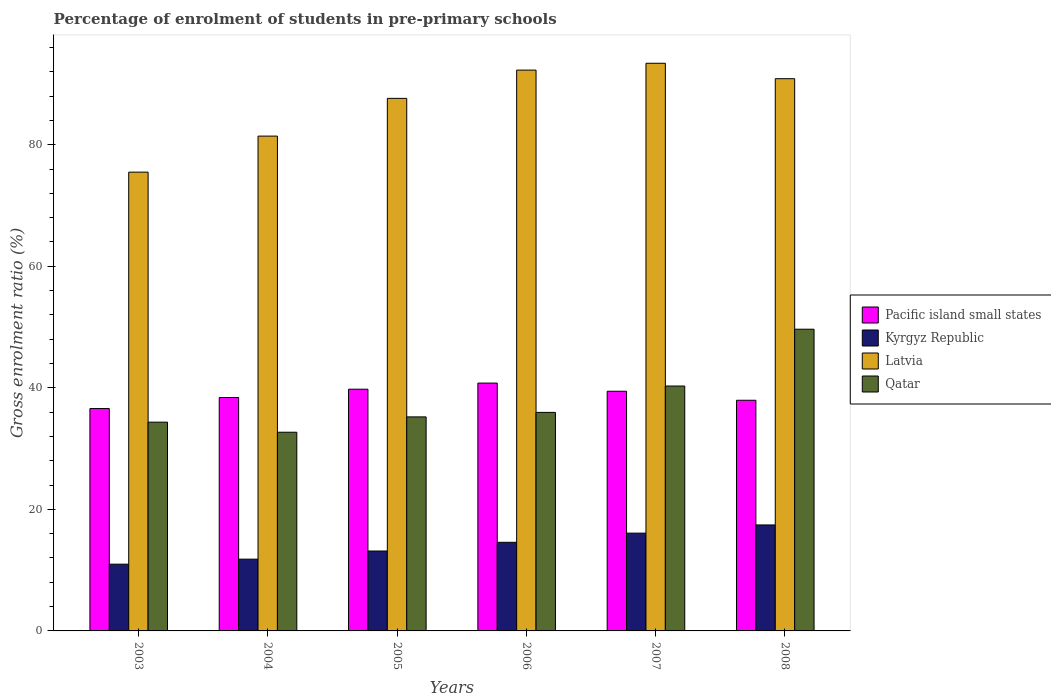How many bars are there on the 5th tick from the left?
Your answer should be compact. 4. What is the label of the 3rd group of bars from the left?
Offer a very short reply. 2005. What is the percentage of students enrolled in pre-primary schools in Pacific island small states in 2006?
Ensure brevity in your answer.  40.78. Across all years, what is the maximum percentage of students enrolled in pre-primary schools in Kyrgyz Republic?
Provide a succinct answer. 17.44. Across all years, what is the minimum percentage of students enrolled in pre-primary schools in Pacific island small states?
Your response must be concise. 36.59. In which year was the percentage of students enrolled in pre-primary schools in Kyrgyz Republic maximum?
Keep it short and to the point. 2008. In which year was the percentage of students enrolled in pre-primary schools in Latvia minimum?
Give a very brief answer. 2003. What is the total percentage of students enrolled in pre-primary schools in Pacific island small states in the graph?
Offer a terse response. 232.95. What is the difference between the percentage of students enrolled in pre-primary schools in Pacific island small states in 2006 and that in 2007?
Keep it short and to the point. 1.34. What is the difference between the percentage of students enrolled in pre-primary schools in Qatar in 2008 and the percentage of students enrolled in pre-primary schools in Latvia in 2004?
Keep it short and to the point. -31.78. What is the average percentage of students enrolled in pre-primary schools in Pacific island small states per year?
Give a very brief answer. 38.83. In the year 2007, what is the difference between the percentage of students enrolled in pre-primary schools in Latvia and percentage of students enrolled in pre-primary schools in Pacific island small states?
Provide a short and direct response. 53.97. What is the ratio of the percentage of students enrolled in pre-primary schools in Latvia in 2004 to that in 2008?
Keep it short and to the point. 0.9. Is the percentage of students enrolled in pre-primary schools in Kyrgyz Republic in 2003 less than that in 2004?
Provide a short and direct response. Yes. Is the difference between the percentage of students enrolled in pre-primary schools in Latvia in 2004 and 2008 greater than the difference between the percentage of students enrolled in pre-primary schools in Pacific island small states in 2004 and 2008?
Keep it short and to the point. No. What is the difference between the highest and the second highest percentage of students enrolled in pre-primary schools in Kyrgyz Republic?
Ensure brevity in your answer.  1.35. What is the difference between the highest and the lowest percentage of students enrolled in pre-primary schools in Kyrgyz Republic?
Offer a terse response. 6.45. In how many years, is the percentage of students enrolled in pre-primary schools in Latvia greater than the average percentage of students enrolled in pre-primary schools in Latvia taken over all years?
Provide a succinct answer. 4. Is the sum of the percentage of students enrolled in pre-primary schools in Kyrgyz Republic in 2005 and 2006 greater than the maximum percentage of students enrolled in pre-primary schools in Latvia across all years?
Offer a very short reply. No. Is it the case that in every year, the sum of the percentage of students enrolled in pre-primary schools in Kyrgyz Republic and percentage of students enrolled in pre-primary schools in Pacific island small states is greater than the sum of percentage of students enrolled in pre-primary schools in Qatar and percentage of students enrolled in pre-primary schools in Latvia?
Provide a succinct answer. No. What does the 3rd bar from the left in 2007 represents?
Provide a short and direct response. Latvia. What does the 3rd bar from the right in 2005 represents?
Make the answer very short. Kyrgyz Republic. What is the difference between two consecutive major ticks on the Y-axis?
Your answer should be very brief. 20. Does the graph contain grids?
Provide a short and direct response. No. How many legend labels are there?
Keep it short and to the point. 4. What is the title of the graph?
Give a very brief answer. Percentage of enrolment of students in pre-primary schools. What is the label or title of the Y-axis?
Give a very brief answer. Gross enrolment ratio (%). What is the Gross enrolment ratio (%) in Pacific island small states in 2003?
Provide a short and direct response. 36.59. What is the Gross enrolment ratio (%) of Kyrgyz Republic in 2003?
Your answer should be very brief. 10.99. What is the Gross enrolment ratio (%) of Latvia in 2003?
Your response must be concise. 75.5. What is the Gross enrolment ratio (%) of Qatar in 2003?
Ensure brevity in your answer.  34.35. What is the Gross enrolment ratio (%) of Pacific island small states in 2004?
Ensure brevity in your answer.  38.41. What is the Gross enrolment ratio (%) in Kyrgyz Republic in 2004?
Your answer should be compact. 11.81. What is the Gross enrolment ratio (%) of Latvia in 2004?
Ensure brevity in your answer.  81.43. What is the Gross enrolment ratio (%) of Qatar in 2004?
Your answer should be very brief. 32.7. What is the Gross enrolment ratio (%) of Pacific island small states in 2005?
Give a very brief answer. 39.78. What is the Gross enrolment ratio (%) of Kyrgyz Republic in 2005?
Provide a succinct answer. 13.15. What is the Gross enrolment ratio (%) in Latvia in 2005?
Your answer should be compact. 87.63. What is the Gross enrolment ratio (%) of Qatar in 2005?
Your response must be concise. 35.22. What is the Gross enrolment ratio (%) of Pacific island small states in 2006?
Offer a terse response. 40.78. What is the Gross enrolment ratio (%) of Kyrgyz Republic in 2006?
Provide a succinct answer. 14.58. What is the Gross enrolment ratio (%) of Latvia in 2006?
Provide a short and direct response. 92.29. What is the Gross enrolment ratio (%) of Qatar in 2006?
Make the answer very short. 35.96. What is the Gross enrolment ratio (%) of Pacific island small states in 2007?
Keep it short and to the point. 39.44. What is the Gross enrolment ratio (%) of Kyrgyz Republic in 2007?
Your answer should be very brief. 16.09. What is the Gross enrolment ratio (%) of Latvia in 2007?
Provide a short and direct response. 93.41. What is the Gross enrolment ratio (%) of Qatar in 2007?
Ensure brevity in your answer.  40.3. What is the Gross enrolment ratio (%) in Pacific island small states in 2008?
Ensure brevity in your answer.  37.96. What is the Gross enrolment ratio (%) in Kyrgyz Republic in 2008?
Provide a short and direct response. 17.44. What is the Gross enrolment ratio (%) in Latvia in 2008?
Your answer should be compact. 90.87. What is the Gross enrolment ratio (%) of Qatar in 2008?
Ensure brevity in your answer.  49.65. Across all years, what is the maximum Gross enrolment ratio (%) in Pacific island small states?
Your response must be concise. 40.78. Across all years, what is the maximum Gross enrolment ratio (%) in Kyrgyz Republic?
Ensure brevity in your answer.  17.44. Across all years, what is the maximum Gross enrolment ratio (%) in Latvia?
Offer a very short reply. 93.41. Across all years, what is the maximum Gross enrolment ratio (%) of Qatar?
Your answer should be very brief. 49.65. Across all years, what is the minimum Gross enrolment ratio (%) of Pacific island small states?
Ensure brevity in your answer.  36.59. Across all years, what is the minimum Gross enrolment ratio (%) of Kyrgyz Republic?
Provide a short and direct response. 10.99. Across all years, what is the minimum Gross enrolment ratio (%) of Latvia?
Provide a short and direct response. 75.5. Across all years, what is the minimum Gross enrolment ratio (%) of Qatar?
Your response must be concise. 32.7. What is the total Gross enrolment ratio (%) of Pacific island small states in the graph?
Make the answer very short. 232.95. What is the total Gross enrolment ratio (%) in Kyrgyz Republic in the graph?
Your answer should be very brief. 84.06. What is the total Gross enrolment ratio (%) of Latvia in the graph?
Your response must be concise. 521.13. What is the total Gross enrolment ratio (%) of Qatar in the graph?
Ensure brevity in your answer.  228.18. What is the difference between the Gross enrolment ratio (%) in Pacific island small states in 2003 and that in 2004?
Give a very brief answer. -1.81. What is the difference between the Gross enrolment ratio (%) in Kyrgyz Republic in 2003 and that in 2004?
Your answer should be compact. -0.83. What is the difference between the Gross enrolment ratio (%) in Latvia in 2003 and that in 2004?
Ensure brevity in your answer.  -5.93. What is the difference between the Gross enrolment ratio (%) of Qatar in 2003 and that in 2004?
Make the answer very short. 1.66. What is the difference between the Gross enrolment ratio (%) of Pacific island small states in 2003 and that in 2005?
Offer a terse response. -3.18. What is the difference between the Gross enrolment ratio (%) of Kyrgyz Republic in 2003 and that in 2005?
Provide a short and direct response. -2.17. What is the difference between the Gross enrolment ratio (%) of Latvia in 2003 and that in 2005?
Give a very brief answer. -12.14. What is the difference between the Gross enrolment ratio (%) of Qatar in 2003 and that in 2005?
Provide a short and direct response. -0.86. What is the difference between the Gross enrolment ratio (%) in Pacific island small states in 2003 and that in 2006?
Offer a very short reply. -4.19. What is the difference between the Gross enrolment ratio (%) of Kyrgyz Republic in 2003 and that in 2006?
Offer a terse response. -3.6. What is the difference between the Gross enrolment ratio (%) of Latvia in 2003 and that in 2006?
Give a very brief answer. -16.79. What is the difference between the Gross enrolment ratio (%) in Qatar in 2003 and that in 2006?
Provide a succinct answer. -1.6. What is the difference between the Gross enrolment ratio (%) in Pacific island small states in 2003 and that in 2007?
Provide a short and direct response. -2.85. What is the difference between the Gross enrolment ratio (%) of Kyrgyz Republic in 2003 and that in 2007?
Provide a succinct answer. -5.11. What is the difference between the Gross enrolment ratio (%) in Latvia in 2003 and that in 2007?
Make the answer very short. -17.91. What is the difference between the Gross enrolment ratio (%) of Qatar in 2003 and that in 2007?
Ensure brevity in your answer.  -5.95. What is the difference between the Gross enrolment ratio (%) of Pacific island small states in 2003 and that in 2008?
Your response must be concise. -1.37. What is the difference between the Gross enrolment ratio (%) of Kyrgyz Republic in 2003 and that in 2008?
Keep it short and to the point. -6.45. What is the difference between the Gross enrolment ratio (%) of Latvia in 2003 and that in 2008?
Offer a very short reply. -15.37. What is the difference between the Gross enrolment ratio (%) in Qatar in 2003 and that in 2008?
Your answer should be very brief. -15.29. What is the difference between the Gross enrolment ratio (%) of Pacific island small states in 2004 and that in 2005?
Offer a terse response. -1.37. What is the difference between the Gross enrolment ratio (%) in Kyrgyz Republic in 2004 and that in 2005?
Offer a terse response. -1.34. What is the difference between the Gross enrolment ratio (%) in Latvia in 2004 and that in 2005?
Offer a very short reply. -6.21. What is the difference between the Gross enrolment ratio (%) in Qatar in 2004 and that in 2005?
Ensure brevity in your answer.  -2.52. What is the difference between the Gross enrolment ratio (%) in Pacific island small states in 2004 and that in 2006?
Provide a succinct answer. -2.38. What is the difference between the Gross enrolment ratio (%) of Kyrgyz Republic in 2004 and that in 2006?
Provide a succinct answer. -2.77. What is the difference between the Gross enrolment ratio (%) in Latvia in 2004 and that in 2006?
Keep it short and to the point. -10.86. What is the difference between the Gross enrolment ratio (%) in Qatar in 2004 and that in 2006?
Your answer should be very brief. -3.26. What is the difference between the Gross enrolment ratio (%) of Pacific island small states in 2004 and that in 2007?
Offer a terse response. -1.04. What is the difference between the Gross enrolment ratio (%) of Kyrgyz Republic in 2004 and that in 2007?
Keep it short and to the point. -4.28. What is the difference between the Gross enrolment ratio (%) in Latvia in 2004 and that in 2007?
Your answer should be very brief. -11.99. What is the difference between the Gross enrolment ratio (%) of Qatar in 2004 and that in 2007?
Provide a succinct answer. -7.6. What is the difference between the Gross enrolment ratio (%) of Pacific island small states in 2004 and that in 2008?
Ensure brevity in your answer.  0.45. What is the difference between the Gross enrolment ratio (%) of Kyrgyz Republic in 2004 and that in 2008?
Give a very brief answer. -5.63. What is the difference between the Gross enrolment ratio (%) in Latvia in 2004 and that in 2008?
Provide a short and direct response. -9.45. What is the difference between the Gross enrolment ratio (%) in Qatar in 2004 and that in 2008?
Your answer should be very brief. -16.95. What is the difference between the Gross enrolment ratio (%) of Pacific island small states in 2005 and that in 2006?
Provide a succinct answer. -1.01. What is the difference between the Gross enrolment ratio (%) of Kyrgyz Republic in 2005 and that in 2006?
Provide a succinct answer. -1.43. What is the difference between the Gross enrolment ratio (%) of Latvia in 2005 and that in 2006?
Your answer should be compact. -4.65. What is the difference between the Gross enrolment ratio (%) of Qatar in 2005 and that in 2006?
Give a very brief answer. -0.74. What is the difference between the Gross enrolment ratio (%) in Pacific island small states in 2005 and that in 2007?
Offer a very short reply. 0.33. What is the difference between the Gross enrolment ratio (%) of Kyrgyz Republic in 2005 and that in 2007?
Your answer should be very brief. -2.94. What is the difference between the Gross enrolment ratio (%) in Latvia in 2005 and that in 2007?
Offer a very short reply. -5.78. What is the difference between the Gross enrolment ratio (%) in Qatar in 2005 and that in 2007?
Offer a very short reply. -5.08. What is the difference between the Gross enrolment ratio (%) in Pacific island small states in 2005 and that in 2008?
Provide a succinct answer. 1.82. What is the difference between the Gross enrolment ratio (%) in Kyrgyz Republic in 2005 and that in 2008?
Offer a very short reply. -4.29. What is the difference between the Gross enrolment ratio (%) of Latvia in 2005 and that in 2008?
Offer a very short reply. -3.24. What is the difference between the Gross enrolment ratio (%) in Qatar in 2005 and that in 2008?
Your answer should be compact. -14.43. What is the difference between the Gross enrolment ratio (%) of Pacific island small states in 2006 and that in 2007?
Offer a terse response. 1.34. What is the difference between the Gross enrolment ratio (%) in Kyrgyz Republic in 2006 and that in 2007?
Offer a very short reply. -1.51. What is the difference between the Gross enrolment ratio (%) in Latvia in 2006 and that in 2007?
Make the answer very short. -1.13. What is the difference between the Gross enrolment ratio (%) of Qatar in 2006 and that in 2007?
Your response must be concise. -4.34. What is the difference between the Gross enrolment ratio (%) of Pacific island small states in 2006 and that in 2008?
Offer a terse response. 2.83. What is the difference between the Gross enrolment ratio (%) in Kyrgyz Republic in 2006 and that in 2008?
Ensure brevity in your answer.  -2.85. What is the difference between the Gross enrolment ratio (%) in Latvia in 2006 and that in 2008?
Provide a succinct answer. 1.41. What is the difference between the Gross enrolment ratio (%) of Qatar in 2006 and that in 2008?
Offer a very short reply. -13.69. What is the difference between the Gross enrolment ratio (%) in Pacific island small states in 2007 and that in 2008?
Keep it short and to the point. 1.48. What is the difference between the Gross enrolment ratio (%) in Kyrgyz Republic in 2007 and that in 2008?
Your response must be concise. -1.35. What is the difference between the Gross enrolment ratio (%) of Latvia in 2007 and that in 2008?
Give a very brief answer. 2.54. What is the difference between the Gross enrolment ratio (%) of Qatar in 2007 and that in 2008?
Your answer should be compact. -9.35. What is the difference between the Gross enrolment ratio (%) of Pacific island small states in 2003 and the Gross enrolment ratio (%) of Kyrgyz Republic in 2004?
Give a very brief answer. 24.78. What is the difference between the Gross enrolment ratio (%) of Pacific island small states in 2003 and the Gross enrolment ratio (%) of Latvia in 2004?
Your response must be concise. -44.83. What is the difference between the Gross enrolment ratio (%) in Pacific island small states in 2003 and the Gross enrolment ratio (%) in Qatar in 2004?
Keep it short and to the point. 3.89. What is the difference between the Gross enrolment ratio (%) in Kyrgyz Republic in 2003 and the Gross enrolment ratio (%) in Latvia in 2004?
Make the answer very short. -70.44. What is the difference between the Gross enrolment ratio (%) of Kyrgyz Republic in 2003 and the Gross enrolment ratio (%) of Qatar in 2004?
Ensure brevity in your answer.  -21.71. What is the difference between the Gross enrolment ratio (%) of Latvia in 2003 and the Gross enrolment ratio (%) of Qatar in 2004?
Offer a very short reply. 42.8. What is the difference between the Gross enrolment ratio (%) in Pacific island small states in 2003 and the Gross enrolment ratio (%) in Kyrgyz Republic in 2005?
Keep it short and to the point. 23.44. What is the difference between the Gross enrolment ratio (%) of Pacific island small states in 2003 and the Gross enrolment ratio (%) of Latvia in 2005?
Keep it short and to the point. -51.04. What is the difference between the Gross enrolment ratio (%) in Pacific island small states in 2003 and the Gross enrolment ratio (%) in Qatar in 2005?
Your answer should be compact. 1.37. What is the difference between the Gross enrolment ratio (%) in Kyrgyz Republic in 2003 and the Gross enrolment ratio (%) in Latvia in 2005?
Make the answer very short. -76.65. What is the difference between the Gross enrolment ratio (%) of Kyrgyz Republic in 2003 and the Gross enrolment ratio (%) of Qatar in 2005?
Offer a terse response. -24.23. What is the difference between the Gross enrolment ratio (%) of Latvia in 2003 and the Gross enrolment ratio (%) of Qatar in 2005?
Offer a terse response. 40.28. What is the difference between the Gross enrolment ratio (%) in Pacific island small states in 2003 and the Gross enrolment ratio (%) in Kyrgyz Republic in 2006?
Your answer should be compact. 22.01. What is the difference between the Gross enrolment ratio (%) of Pacific island small states in 2003 and the Gross enrolment ratio (%) of Latvia in 2006?
Give a very brief answer. -55.69. What is the difference between the Gross enrolment ratio (%) in Pacific island small states in 2003 and the Gross enrolment ratio (%) in Qatar in 2006?
Your response must be concise. 0.63. What is the difference between the Gross enrolment ratio (%) of Kyrgyz Republic in 2003 and the Gross enrolment ratio (%) of Latvia in 2006?
Provide a short and direct response. -81.3. What is the difference between the Gross enrolment ratio (%) in Kyrgyz Republic in 2003 and the Gross enrolment ratio (%) in Qatar in 2006?
Provide a succinct answer. -24.97. What is the difference between the Gross enrolment ratio (%) in Latvia in 2003 and the Gross enrolment ratio (%) in Qatar in 2006?
Make the answer very short. 39.54. What is the difference between the Gross enrolment ratio (%) in Pacific island small states in 2003 and the Gross enrolment ratio (%) in Kyrgyz Republic in 2007?
Your response must be concise. 20.5. What is the difference between the Gross enrolment ratio (%) in Pacific island small states in 2003 and the Gross enrolment ratio (%) in Latvia in 2007?
Your answer should be compact. -56.82. What is the difference between the Gross enrolment ratio (%) in Pacific island small states in 2003 and the Gross enrolment ratio (%) in Qatar in 2007?
Make the answer very short. -3.71. What is the difference between the Gross enrolment ratio (%) of Kyrgyz Republic in 2003 and the Gross enrolment ratio (%) of Latvia in 2007?
Offer a terse response. -82.43. What is the difference between the Gross enrolment ratio (%) of Kyrgyz Republic in 2003 and the Gross enrolment ratio (%) of Qatar in 2007?
Your answer should be very brief. -29.32. What is the difference between the Gross enrolment ratio (%) of Latvia in 2003 and the Gross enrolment ratio (%) of Qatar in 2007?
Offer a terse response. 35.2. What is the difference between the Gross enrolment ratio (%) of Pacific island small states in 2003 and the Gross enrolment ratio (%) of Kyrgyz Republic in 2008?
Your answer should be very brief. 19.15. What is the difference between the Gross enrolment ratio (%) in Pacific island small states in 2003 and the Gross enrolment ratio (%) in Latvia in 2008?
Make the answer very short. -54.28. What is the difference between the Gross enrolment ratio (%) in Pacific island small states in 2003 and the Gross enrolment ratio (%) in Qatar in 2008?
Your answer should be very brief. -13.06. What is the difference between the Gross enrolment ratio (%) in Kyrgyz Republic in 2003 and the Gross enrolment ratio (%) in Latvia in 2008?
Give a very brief answer. -79.89. What is the difference between the Gross enrolment ratio (%) in Kyrgyz Republic in 2003 and the Gross enrolment ratio (%) in Qatar in 2008?
Provide a short and direct response. -38.66. What is the difference between the Gross enrolment ratio (%) in Latvia in 2003 and the Gross enrolment ratio (%) in Qatar in 2008?
Your response must be concise. 25.85. What is the difference between the Gross enrolment ratio (%) of Pacific island small states in 2004 and the Gross enrolment ratio (%) of Kyrgyz Republic in 2005?
Give a very brief answer. 25.26. What is the difference between the Gross enrolment ratio (%) in Pacific island small states in 2004 and the Gross enrolment ratio (%) in Latvia in 2005?
Offer a very short reply. -49.23. What is the difference between the Gross enrolment ratio (%) of Pacific island small states in 2004 and the Gross enrolment ratio (%) of Qatar in 2005?
Provide a short and direct response. 3.19. What is the difference between the Gross enrolment ratio (%) in Kyrgyz Republic in 2004 and the Gross enrolment ratio (%) in Latvia in 2005?
Your response must be concise. -75.82. What is the difference between the Gross enrolment ratio (%) in Kyrgyz Republic in 2004 and the Gross enrolment ratio (%) in Qatar in 2005?
Offer a very short reply. -23.41. What is the difference between the Gross enrolment ratio (%) of Latvia in 2004 and the Gross enrolment ratio (%) of Qatar in 2005?
Give a very brief answer. 46.21. What is the difference between the Gross enrolment ratio (%) in Pacific island small states in 2004 and the Gross enrolment ratio (%) in Kyrgyz Republic in 2006?
Provide a short and direct response. 23.82. What is the difference between the Gross enrolment ratio (%) of Pacific island small states in 2004 and the Gross enrolment ratio (%) of Latvia in 2006?
Provide a succinct answer. -53.88. What is the difference between the Gross enrolment ratio (%) in Pacific island small states in 2004 and the Gross enrolment ratio (%) in Qatar in 2006?
Your response must be concise. 2.45. What is the difference between the Gross enrolment ratio (%) in Kyrgyz Republic in 2004 and the Gross enrolment ratio (%) in Latvia in 2006?
Provide a succinct answer. -80.47. What is the difference between the Gross enrolment ratio (%) of Kyrgyz Republic in 2004 and the Gross enrolment ratio (%) of Qatar in 2006?
Provide a short and direct response. -24.15. What is the difference between the Gross enrolment ratio (%) in Latvia in 2004 and the Gross enrolment ratio (%) in Qatar in 2006?
Offer a very short reply. 45.47. What is the difference between the Gross enrolment ratio (%) in Pacific island small states in 2004 and the Gross enrolment ratio (%) in Kyrgyz Republic in 2007?
Your answer should be compact. 22.31. What is the difference between the Gross enrolment ratio (%) of Pacific island small states in 2004 and the Gross enrolment ratio (%) of Latvia in 2007?
Your answer should be compact. -55.01. What is the difference between the Gross enrolment ratio (%) of Pacific island small states in 2004 and the Gross enrolment ratio (%) of Qatar in 2007?
Your answer should be compact. -1.89. What is the difference between the Gross enrolment ratio (%) in Kyrgyz Republic in 2004 and the Gross enrolment ratio (%) in Latvia in 2007?
Make the answer very short. -81.6. What is the difference between the Gross enrolment ratio (%) of Kyrgyz Republic in 2004 and the Gross enrolment ratio (%) of Qatar in 2007?
Give a very brief answer. -28.49. What is the difference between the Gross enrolment ratio (%) in Latvia in 2004 and the Gross enrolment ratio (%) in Qatar in 2007?
Your response must be concise. 41.13. What is the difference between the Gross enrolment ratio (%) of Pacific island small states in 2004 and the Gross enrolment ratio (%) of Kyrgyz Republic in 2008?
Offer a terse response. 20.97. What is the difference between the Gross enrolment ratio (%) of Pacific island small states in 2004 and the Gross enrolment ratio (%) of Latvia in 2008?
Provide a short and direct response. -52.47. What is the difference between the Gross enrolment ratio (%) in Pacific island small states in 2004 and the Gross enrolment ratio (%) in Qatar in 2008?
Offer a very short reply. -11.24. What is the difference between the Gross enrolment ratio (%) of Kyrgyz Republic in 2004 and the Gross enrolment ratio (%) of Latvia in 2008?
Provide a short and direct response. -79.06. What is the difference between the Gross enrolment ratio (%) in Kyrgyz Republic in 2004 and the Gross enrolment ratio (%) in Qatar in 2008?
Ensure brevity in your answer.  -37.84. What is the difference between the Gross enrolment ratio (%) in Latvia in 2004 and the Gross enrolment ratio (%) in Qatar in 2008?
Provide a succinct answer. 31.78. What is the difference between the Gross enrolment ratio (%) of Pacific island small states in 2005 and the Gross enrolment ratio (%) of Kyrgyz Republic in 2006?
Keep it short and to the point. 25.19. What is the difference between the Gross enrolment ratio (%) of Pacific island small states in 2005 and the Gross enrolment ratio (%) of Latvia in 2006?
Keep it short and to the point. -52.51. What is the difference between the Gross enrolment ratio (%) of Pacific island small states in 2005 and the Gross enrolment ratio (%) of Qatar in 2006?
Give a very brief answer. 3.82. What is the difference between the Gross enrolment ratio (%) of Kyrgyz Republic in 2005 and the Gross enrolment ratio (%) of Latvia in 2006?
Your answer should be very brief. -79.14. What is the difference between the Gross enrolment ratio (%) in Kyrgyz Republic in 2005 and the Gross enrolment ratio (%) in Qatar in 2006?
Offer a terse response. -22.81. What is the difference between the Gross enrolment ratio (%) of Latvia in 2005 and the Gross enrolment ratio (%) of Qatar in 2006?
Provide a succinct answer. 51.68. What is the difference between the Gross enrolment ratio (%) of Pacific island small states in 2005 and the Gross enrolment ratio (%) of Kyrgyz Republic in 2007?
Provide a succinct answer. 23.68. What is the difference between the Gross enrolment ratio (%) in Pacific island small states in 2005 and the Gross enrolment ratio (%) in Latvia in 2007?
Ensure brevity in your answer.  -53.64. What is the difference between the Gross enrolment ratio (%) of Pacific island small states in 2005 and the Gross enrolment ratio (%) of Qatar in 2007?
Your answer should be compact. -0.52. What is the difference between the Gross enrolment ratio (%) in Kyrgyz Republic in 2005 and the Gross enrolment ratio (%) in Latvia in 2007?
Your response must be concise. -80.26. What is the difference between the Gross enrolment ratio (%) of Kyrgyz Republic in 2005 and the Gross enrolment ratio (%) of Qatar in 2007?
Offer a very short reply. -27.15. What is the difference between the Gross enrolment ratio (%) of Latvia in 2005 and the Gross enrolment ratio (%) of Qatar in 2007?
Offer a very short reply. 47.33. What is the difference between the Gross enrolment ratio (%) of Pacific island small states in 2005 and the Gross enrolment ratio (%) of Kyrgyz Republic in 2008?
Provide a short and direct response. 22.34. What is the difference between the Gross enrolment ratio (%) in Pacific island small states in 2005 and the Gross enrolment ratio (%) in Latvia in 2008?
Offer a terse response. -51.1. What is the difference between the Gross enrolment ratio (%) of Pacific island small states in 2005 and the Gross enrolment ratio (%) of Qatar in 2008?
Your answer should be very brief. -9.87. What is the difference between the Gross enrolment ratio (%) of Kyrgyz Republic in 2005 and the Gross enrolment ratio (%) of Latvia in 2008?
Provide a succinct answer. -77.72. What is the difference between the Gross enrolment ratio (%) of Kyrgyz Republic in 2005 and the Gross enrolment ratio (%) of Qatar in 2008?
Offer a terse response. -36.5. What is the difference between the Gross enrolment ratio (%) of Latvia in 2005 and the Gross enrolment ratio (%) of Qatar in 2008?
Keep it short and to the point. 37.99. What is the difference between the Gross enrolment ratio (%) of Pacific island small states in 2006 and the Gross enrolment ratio (%) of Kyrgyz Republic in 2007?
Provide a succinct answer. 24.69. What is the difference between the Gross enrolment ratio (%) in Pacific island small states in 2006 and the Gross enrolment ratio (%) in Latvia in 2007?
Provide a short and direct response. -52.63. What is the difference between the Gross enrolment ratio (%) of Pacific island small states in 2006 and the Gross enrolment ratio (%) of Qatar in 2007?
Give a very brief answer. 0.48. What is the difference between the Gross enrolment ratio (%) in Kyrgyz Republic in 2006 and the Gross enrolment ratio (%) in Latvia in 2007?
Keep it short and to the point. -78.83. What is the difference between the Gross enrolment ratio (%) in Kyrgyz Republic in 2006 and the Gross enrolment ratio (%) in Qatar in 2007?
Provide a short and direct response. -25.72. What is the difference between the Gross enrolment ratio (%) of Latvia in 2006 and the Gross enrolment ratio (%) of Qatar in 2007?
Your answer should be very brief. 51.98. What is the difference between the Gross enrolment ratio (%) in Pacific island small states in 2006 and the Gross enrolment ratio (%) in Kyrgyz Republic in 2008?
Ensure brevity in your answer.  23.35. What is the difference between the Gross enrolment ratio (%) of Pacific island small states in 2006 and the Gross enrolment ratio (%) of Latvia in 2008?
Ensure brevity in your answer.  -50.09. What is the difference between the Gross enrolment ratio (%) in Pacific island small states in 2006 and the Gross enrolment ratio (%) in Qatar in 2008?
Provide a succinct answer. -8.87. What is the difference between the Gross enrolment ratio (%) in Kyrgyz Republic in 2006 and the Gross enrolment ratio (%) in Latvia in 2008?
Offer a very short reply. -76.29. What is the difference between the Gross enrolment ratio (%) in Kyrgyz Republic in 2006 and the Gross enrolment ratio (%) in Qatar in 2008?
Provide a short and direct response. -35.07. What is the difference between the Gross enrolment ratio (%) of Latvia in 2006 and the Gross enrolment ratio (%) of Qatar in 2008?
Provide a short and direct response. 42.64. What is the difference between the Gross enrolment ratio (%) in Pacific island small states in 2007 and the Gross enrolment ratio (%) in Kyrgyz Republic in 2008?
Provide a succinct answer. 22. What is the difference between the Gross enrolment ratio (%) in Pacific island small states in 2007 and the Gross enrolment ratio (%) in Latvia in 2008?
Keep it short and to the point. -51.43. What is the difference between the Gross enrolment ratio (%) of Pacific island small states in 2007 and the Gross enrolment ratio (%) of Qatar in 2008?
Provide a succinct answer. -10.21. What is the difference between the Gross enrolment ratio (%) of Kyrgyz Republic in 2007 and the Gross enrolment ratio (%) of Latvia in 2008?
Your response must be concise. -74.78. What is the difference between the Gross enrolment ratio (%) of Kyrgyz Republic in 2007 and the Gross enrolment ratio (%) of Qatar in 2008?
Keep it short and to the point. -33.56. What is the difference between the Gross enrolment ratio (%) of Latvia in 2007 and the Gross enrolment ratio (%) of Qatar in 2008?
Provide a short and direct response. 43.76. What is the average Gross enrolment ratio (%) in Pacific island small states per year?
Offer a terse response. 38.83. What is the average Gross enrolment ratio (%) of Kyrgyz Republic per year?
Your answer should be very brief. 14.01. What is the average Gross enrolment ratio (%) of Latvia per year?
Provide a succinct answer. 86.85. What is the average Gross enrolment ratio (%) in Qatar per year?
Keep it short and to the point. 38.03. In the year 2003, what is the difference between the Gross enrolment ratio (%) in Pacific island small states and Gross enrolment ratio (%) in Kyrgyz Republic?
Offer a very short reply. 25.61. In the year 2003, what is the difference between the Gross enrolment ratio (%) of Pacific island small states and Gross enrolment ratio (%) of Latvia?
Your answer should be compact. -38.91. In the year 2003, what is the difference between the Gross enrolment ratio (%) in Pacific island small states and Gross enrolment ratio (%) in Qatar?
Your answer should be very brief. 2.24. In the year 2003, what is the difference between the Gross enrolment ratio (%) in Kyrgyz Republic and Gross enrolment ratio (%) in Latvia?
Offer a terse response. -64.51. In the year 2003, what is the difference between the Gross enrolment ratio (%) in Kyrgyz Republic and Gross enrolment ratio (%) in Qatar?
Give a very brief answer. -23.37. In the year 2003, what is the difference between the Gross enrolment ratio (%) of Latvia and Gross enrolment ratio (%) of Qatar?
Your answer should be very brief. 41.14. In the year 2004, what is the difference between the Gross enrolment ratio (%) in Pacific island small states and Gross enrolment ratio (%) in Kyrgyz Republic?
Offer a terse response. 26.59. In the year 2004, what is the difference between the Gross enrolment ratio (%) of Pacific island small states and Gross enrolment ratio (%) of Latvia?
Make the answer very short. -43.02. In the year 2004, what is the difference between the Gross enrolment ratio (%) in Pacific island small states and Gross enrolment ratio (%) in Qatar?
Offer a very short reply. 5.71. In the year 2004, what is the difference between the Gross enrolment ratio (%) of Kyrgyz Republic and Gross enrolment ratio (%) of Latvia?
Offer a very short reply. -69.61. In the year 2004, what is the difference between the Gross enrolment ratio (%) of Kyrgyz Republic and Gross enrolment ratio (%) of Qatar?
Give a very brief answer. -20.88. In the year 2004, what is the difference between the Gross enrolment ratio (%) of Latvia and Gross enrolment ratio (%) of Qatar?
Offer a very short reply. 48.73. In the year 2005, what is the difference between the Gross enrolment ratio (%) in Pacific island small states and Gross enrolment ratio (%) in Kyrgyz Republic?
Make the answer very short. 26.63. In the year 2005, what is the difference between the Gross enrolment ratio (%) in Pacific island small states and Gross enrolment ratio (%) in Latvia?
Keep it short and to the point. -47.86. In the year 2005, what is the difference between the Gross enrolment ratio (%) in Pacific island small states and Gross enrolment ratio (%) in Qatar?
Your answer should be very brief. 4.56. In the year 2005, what is the difference between the Gross enrolment ratio (%) of Kyrgyz Republic and Gross enrolment ratio (%) of Latvia?
Your answer should be compact. -74.48. In the year 2005, what is the difference between the Gross enrolment ratio (%) in Kyrgyz Republic and Gross enrolment ratio (%) in Qatar?
Give a very brief answer. -22.07. In the year 2005, what is the difference between the Gross enrolment ratio (%) in Latvia and Gross enrolment ratio (%) in Qatar?
Your answer should be compact. 52.42. In the year 2006, what is the difference between the Gross enrolment ratio (%) in Pacific island small states and Gross enrolment ratio (%) in Kyrgyz Republic?
Offer a very short reply. 26.2. In the year 2006, what is the difference between the Gross enrolment ratio (%) of Pacific island small states and Gross enrolment ratio (%) of Latvia?
Ensure brevity in your answer.  -51.5. In the year 2006, what is the difference between the Gross enrolment ratio (%) of Pacific island small states and Gross enrolment ratio (%) of Qatar?
Offer a terse response. 4.82. In the year 2006, what is the difference between the Gross enrolment ratio (%) of Kyrgyz Republic and Gross enrolment ratio (%) of Latvia?
Offer a very short reply. -77.7. In the year 2006, what is the difference between the Gross enrolment ratio (%) of Kyrgyz Republic and Gross enrolment ratio (%) of Qatar?
Provide a succinct answer. -21.38. In the year 2006, what is the difference between the Gross enrolment ratio (%) in Latvia and Gross enrolment ratio (%) in Qatar?
Give a very brief answer. 56.33. In the year 2007, what is the difference between the Gross enrolment ratio (%) in Pacific island small states and Gross enrolment ratio (%) in Kyrgyz Republic?
Provide a short and direct response. 23.35. In the year 2007, what is the difference between the Gross enrolment ratio (%) of Pacific island small states and Gross enrolment ratio (%) of Latvia?
Your response must be concise. -53.97. In the year 2007, what is the difference between the Gross enrolment ratio (%) of Pacific island small states and Gross enrolment ratio (%) of Qatar?
Ensure brevity in your answer.  -0.86. In the year 2007, what is the difference between the Gross enrolment ratio (%) in Kyrgyz Republic and Gross enrolment ratio (%) in Latvia?
Ensure brevity in your answer.  -77.32. In the year 2007, what is the difference between the Gross enrolment ratio (%) of Kyrgyz Republic and Gross enrolment ratio (%) of Qatar?
Give a very brief answer. -24.21. In the year 2007, what is the difference between the Gross enrolment ratio (%) in Latvia and Gross enrolment ratio (%) in Qatar?
Provide a short and direct response. 53.11. In the year 2008, what is the difference between the Gross enrolment ratio (%) of Pacific island small states and Gross enrolment ratio (%) of Kyrgyz Republic?
Your answer should be very brief. 20.52. In the year 2008, what is the difference between the Gross enrolment ratio (%) in Pacific island small states and Gross enrolment ratio (%) in Latvia?
Offer a very short reply. -52.92. In the year 2008, what is the difference between the Gross enrolment ratio (%) in Pacific island small states and Gross enrolment ratio (%) in Qatar?
Offer a very short reply. -11.69. In the year 2008, what is the difference between the Gross enrolment ratio (%) of Kyrgyz Republic and Gross enrolment ratio (%) of Latvia?
Make the answer very short. -73.43. In the year 2008, what is the difference between the Gross enrolment ratio (%) of Kyrgyz Republic and Gross enrolment ratio (%) of Qatar?
Keep it short and to the point. -32.21. In the year 2008, what is the difference between the Gross enrolment ratio (%) of Latvia and Gross enrolment ratio (%) of Qatar?
Provide a short and direct response. 41.22. What is the ratio of the Gross enrolment ratio (%) of Pacific island small states in 2003 to that in 2004?
Provide a short and direct response. 0.95. What is the ratio of the Gross enrolment ratio (%) in Latvia in 2003 to that in 2004?
Ensure brevity in your answer.  0.93. What is the ratio of the Gross enrolment ratio (%) of Qatar in 2003 to that in 2004?
Your response must be concise. 1.05. What is the ratio of the Gross enrolment ratio (%) of Pacific island small states in 2003 to that in 2005?
Offer a terse response. 0.92. What is the ratio of the Gross enrolment ratio (%) in Kyrgyz Republic in 2003 to that in 2005?
Provide a succinct answer. 0.84. What is the ratio of the Gross enrolment ratio (%) of Latvia in 2003 to that in 2005?
Provide a short and direct response. 0.86. What is the ratio of the Gross enrolment ratio (%) of Qatar in 2003 to that in 2005?
Provide a succinct answer. 0.98. What is the ratio of the Gross enrolment ratio (%) of Pacific island small states in 2003 to that in 2006?
Provide a short and direct response. 0.9. What is the ratio of the Gross enrolment ratio (%) of Kyrgyz Republic in 2003 to that in 2006?
Provide a succinct answer. 0.75. What is the ratio of the Gross enrolment ratio (%) of Latvia in 2003 to that in 2006?
Give a very brief answer. 0.82. What is the ratio of the Gross enrolment ratio (%) of Qatar in 2003 to that in 2006?
Keep it short and to the point. 0.96. What is the ratio of the Gross enrolment ratio (%) of Pacific island small states in 2003 to that in 2007?
Your answer should be compact. 0.93. What is the ratio of the Gross enrolment ratio (%) in Kyrgyz Republic in 2003 to that in 2007?
Make the answer very short. 0.68. What is the ratio of the Gross enrolment ratio (%) of Latvia in 2003 to that in 2007?
Ensure brevity in your answer.  0.81. What is the ratio of the Gross enrolment ratio (%) in Qatar in 2003 to that in 2007?
Provide a short and direct response. 0.85. What is the ratio of the Gross enrolment ratio (%) in Kyrgyz Republic in 2003 to that in 2008?
Offer a very short reply. 0.63. What is the ratio of the Gross enrolment ratio (%) in Latvia in 2003 to that in 2008?
Provide a short and direct response. 0.83. What is the ratio of the Gross enrolment ratio (%) in Qatar in 2003 to that in 2008?
Provide a short and direct response. 0.69. What is the ratio of the Gross enrolment ratio (%) of Pacific island small states in 2004 to that in 2005?
Offer a terse response. 0.97. What is the ratio of the Gross enrolment ratio (%) of Kyrgyz Republic in 2004 to that in 2005?
Ensure brevity in your answer.  0.9. What is the ratio of the Gross enrolment ratio (%) in Latvia in 2004 to that in 2005?
Your answer should be compact. 0.93. What is the ratio of the Gross enrolment ratio (%) in Qatar in 2004 to that in 2005?
Your answer should be compact. 0.93. What is the ratio of the Gross enrolment ratio (%) of Pacific island small states in 2004 to that in 2006?
Offer a terse response. 0.94. What is the ratio of the Gross enrolment ratio (%) in Kyrgyz Republic in 2004 to that in 2006?
Give a very brief answer. 0.81. What is the ratio of the Gross enrolment ratio (%) in Latvia in 2004 to that in 2006?
Your response must be concise. 0.88. What is the ratio of the Gross enrolment ratio (%) of Qatar in 2004 to that in 2006?
Offer a very short reply. 0.91. What is the ratio of the Gross enrolment ratio (%) in Pacific island small states in 2004 to that in 2007?
Provide a succinct answer. 0.97. What is the ratio of the Gross enrolment ratio (%) in Kyrgyz Republic in 2004 to that in 2007?
Offer a very short reply. 0.73. What is the ratio of the Gross enrolment ratio (%) in Latvia in 2004 to that in 2007?
Provide a short and direct response. 0.87. What is the ratio of the Gross enrolment ratio (%) of Qatar in 2004 to that in 2007?
Your answer should be very brief. 0.81. What is the ratio of the Gross enrolment ratio (%) in Pacific island small states in 2004 to that in 2008?
Keep it short and to the point. 1.01. What is the ratio of the Gross enrolment ratio (%) in Kyrgyz Republic in 2004 to that in 2008?
Provide a short and direct response. 0.68. What is the ratio of the Gross enrolment ratio (%) of Latvia in 2004 to that in 2008?
Provide a short and direct response. 0.9. What is the ratio of the Gross enrolment ratio (%) in Qatar in 2004 to that in 2008?
Offer a terse response. 0.66. What is the ratio of the Gross enrolment ratio (%) of Pacific island small states in 2005 to that in 2006?
Make the answer very short. 0.98. What is the ratio of the Gross enrolment ratio (%) in Kyrgyz Republic in 2005 to that in 2006?
Your response must be concise. 0.9. What is the ratio of the Gross enrolment ratio (%) in Latvia in 2005 to that in 2006?
Your answer should be very brief. 0.95. What is the ratio of the Gross enrolment ratio (%) of Qatar in 2005 to that in 2006?
Keep it short and to the point. 0.98. What is the ratio of the Gross enrolment ratio (%) in Pacific island small states in 2005 to that in 2007?
Offer a very short reply. 1.01. What is the ratio of the Gross enrolment ratio (%) in Kyrgyz Republic in 2005 to that in 2007?
Offer a very short reply. 0.82. What is the ratio of the Gross enrolment ratio (%) in Latvia in 2005 to that in 2007?
Provide a short and direct response. 0.94. What is the ratio of the Gross enrolment ratio (%) of Qatar in 2005 to that in 2007?
Ensure brevity in your answer.  0.87. What is the ratio of the Gross enrolment ratio (%) in Pacific island small states in 2005 to that in 2008?
Provide a succinct answer. 1.05. What is the ratio of the Gross enrolment ratio (%) of Kyrgyz Republic in 2005 to that in 2008?
Make the answer very short. 0.75. What is the ratio of the Gross enrolment ratio (%) in Latvia in 2005 to that in 2008?
Offer a terse response. 0.96. What is the ratio of the Gross enrolment ratio (%) of Qatar in 2005 to that in 2008?
Provide a short and direct response. 0.71. What is the ratio of the Gross enrolment ratio (%) of Pacific island small states in 2006 to that in 2007?
Offer a terse response. 1.03. What is the ratio of the Gross enrolment ratio (%) in Kyrgyz Republic in 2006 to that in 2007?
Offer a very short reply. 0.91. What is the ratio of the Gross enrolment ratio (%) in Latvia in 2006 to that in 2007?
Provide a succinct answer. 0.99. What is the ratio of the Gross enrolment ratio (%) in Qatar in 2006 to that in 2007?
Your answer should be very brief. 0.89. What is the ratio of the Gross enrolment ratio (%) in Pacific island small states in 2006 to that in 2008?
Keep it short and to the point. 1.07. What is the ratio of the Gross enrolment ratio (%) of Kyrgyz Republic in 2006 to that in 2008?
Give a very brief answer. 0.84. What is the ratio of the Gross enrolment ratio (%) of Latvia in 2006 to that in 2008?
Offer a very short reply. 1.02. What is the ratio of the Gross enrolment ratio (%) of Qatar in 2006 to that in 2008?
Your answer should be very brief. 0.72. What is the ratio of the Gross enrolment ratio (%) of Pacific island small states in 2007 to that in 2008?
Offer a terse response. 1.04. What is the ratio of the Gross enrolment ratio (%) in Kyrgyz Republic in 2007 to that in 2008?
Offer a terse response. 0.92. What is the ratio of the Gross enrolment ratio (%) of Latvia in 2007 to that in 2008?
Keep it short and to the point. 1.03. What is the ratio of the Gross enrolment ratio (%) in Qatar in 2007 to that in 2008?
Give a very brief answer. 0.81. What is the difference between the highest and the second highest Gross enrolment ratio (%) of Pacific island small states?
Keep it short and to the point. 1.01. What is the difference between the highest and the second highest Gross enrolment ratio (%) of Kyrgyz Republic?
Offer a terse response. 1.35. What is the difference between the highest and the second highest Gross enrolment ratio (%) in Latvia?
Offer a very short reply. 1.13. What is the difference between the highest and the second highest Gross enrolment ratio (%) in Qatar?
Provide a succinct answer. 9.35. What is the difference between the highest and the lowest Gross enrolment ratio (%) in Pacific island small states?
Give a very brief answer. 4.19. What is the difference between the highest and the lowest Gross enrolment ratio (%) of Kyrgyz Republic?
Your response must be concise. 6.45. What is the difference between the highest and the lowest Gross enrolment ratio (%) of Latvia?
Provide a succinct answer. 17.91. What is the difference between the highest and the lowest Gross enrolment ratio (%) in Qatar?
Your response must be concise. 16.95. 